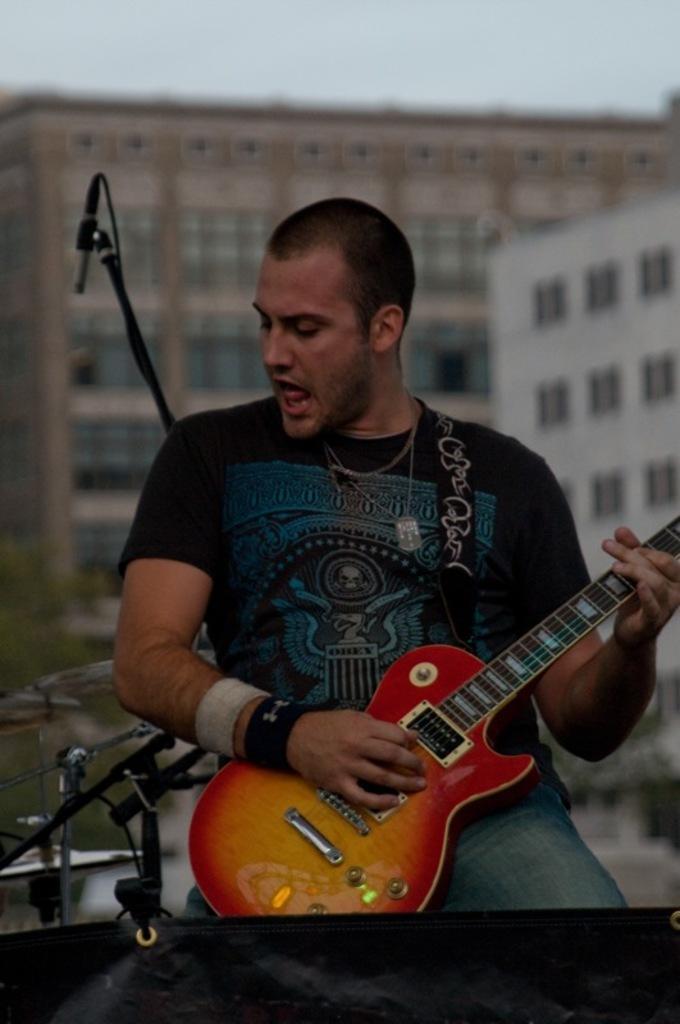How would you summarize this image in a sentence or two? A man is playing guitar. Behind him there is a microphone,buildings and sky. 